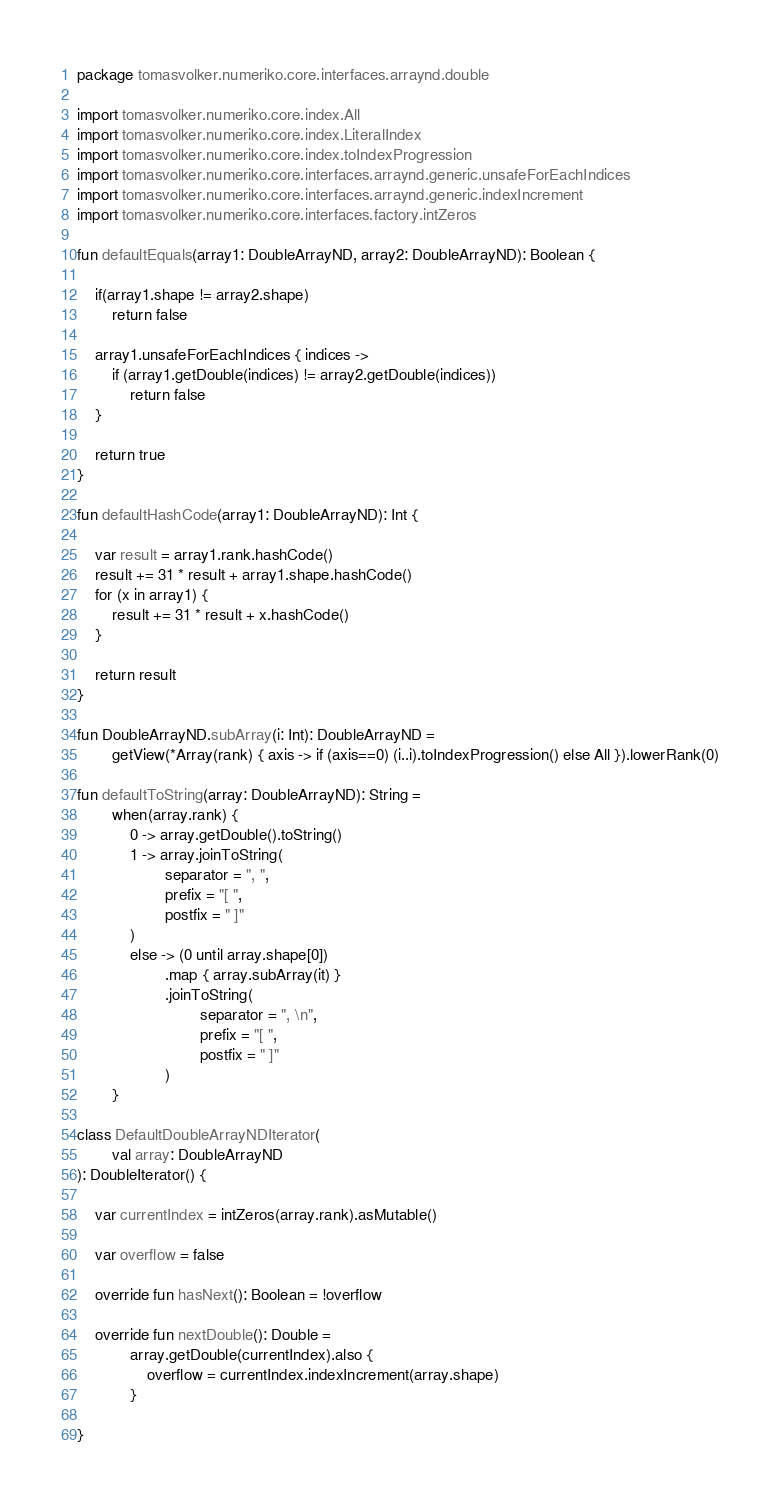<code> <loc_0><loc_0><loc_500><loc_500><_Kotlin_>package tomasvolker.numeriko.core.interfaces.arraynd.double

import tomasvolker.numeriko.core.index.All
import tomasvolker.numeriko.core.index.LiteralIndex
import tomasvolker.numeriko.core.index.toIndexProgression
import tomasvolker.numeriko.core.interfaces.arraynd.generic.unsafeForEachIndices
import tomasvolker.numeriko.core.interfaces.arraynd.generic.indexIncrement
import tomasvolker.numeriko.core.interfaces.factory.intZeros

fun defaultEquals(array1: DoubleArrayND, array2: DoubleArrayND): Boolean {

    if(array1.shape != array2.shape)
        return false

    array1.unsafeForEachIndices { indices ->
        if (array1.getDouble(indices) != array2.getDouble(indices))
            return false
    }

    return true
}

fun defaultHashCode(array1: DoubleArrayND): Int {

    var result = array1.rank.hashCode()
    result += 31 * result + array1.shape.hashCode()
    for (x in array1) {
        result += 31 * result + x.hashCode()
    }

    return result
}

fun DoubleArrayND.subArray(i: Int): DoubleArrayND =
        getView(*Array(rank) { axis -> if (axis==0) (i..i).toIndexProgression() else All }).lowerRank(0)

fun defaultToString(array: DoubleArrayND): String =
        when(array.rank) {
            0 -> array.getDouble().toString()
            1 -> array.joinToString(
                    separator = ", ",
                    prefix = "[ ",
                    postfix = " ]"
            )
            else -> (0 until array.shape[0])
                    .map { array.subArray(it) }
                    .joinToString(
                            separator = ", \n",
                            prefix = "[ ",
                            postfix = " ]"
                    )
        }

class DefaultDoubleArrayNDIterator(
        val array: DoubleArrayND
): DoubleIterator() {

    var currentIndex = intZeros(array.rank).asMutable()

    var overflow = false

    override fun hasNext(): Boolean = !overflow

    override fun nextDouble(): Double =
            array.getDouble(currentIndex).also {
                overflow = currentIndex.indexIncrement(array.shape)
            }

}
</code> 